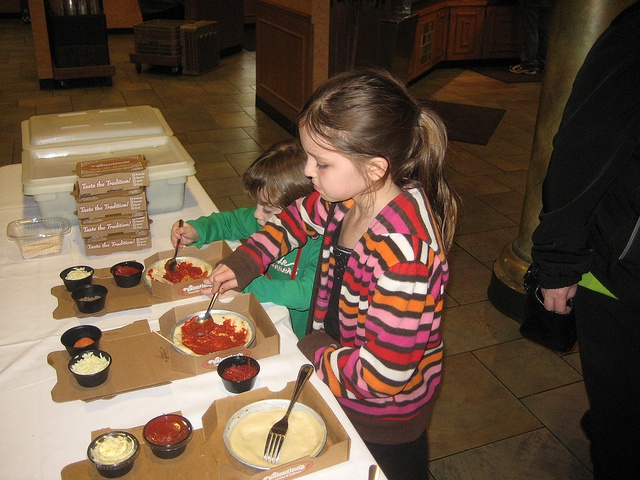Describe the objects in this image and their specific colors. I can see people in black, maroon, brown, and lightpink tones, people in black, brown, darkgreen, and olive tones, people in black, teal, darkgreen, and maroon tones, bowl in black, khaki, ivory, tan, and gray tones, and pizza in black, brown, tan, and gray tones in this image. 